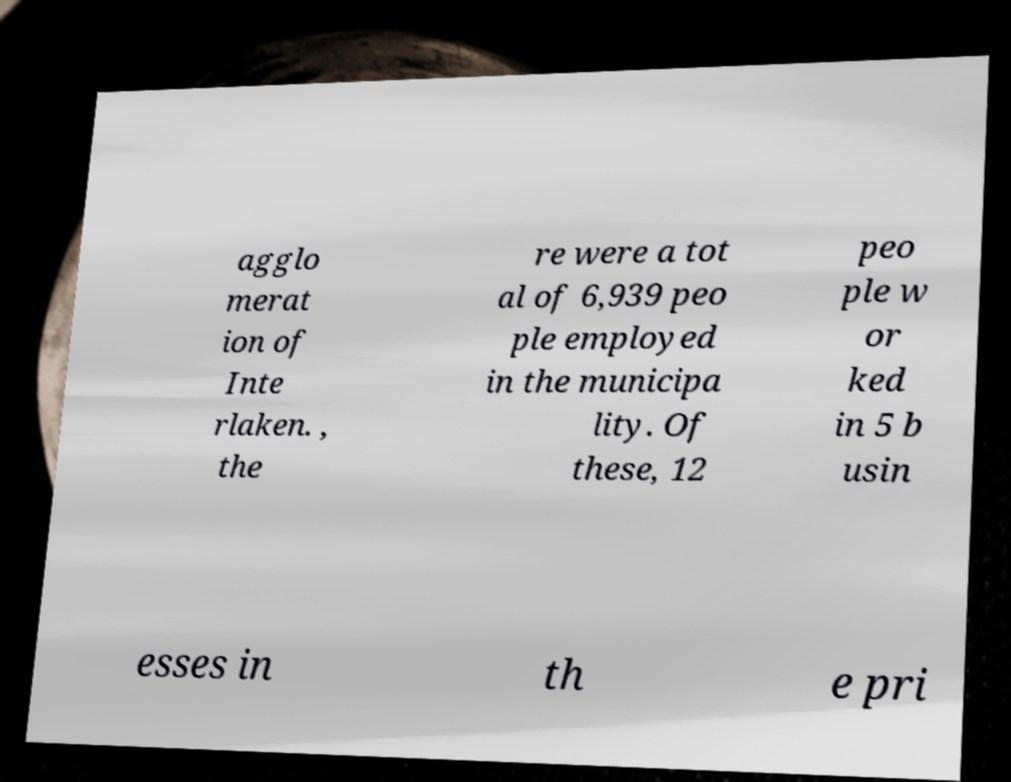Could you assist in decoding the text presented in this image and type it out clearly? agglo merat ion of Inte rlaken. , the re were a tot al of 6,939 peo ple employed in the municipa lity. Of these, 12 peo ple w or ked in 5 b usin esses in th e pri 